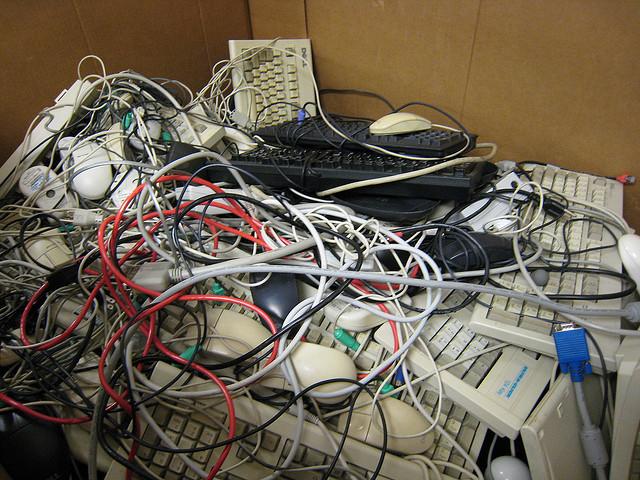Are these wires tangled?
Write a very short answer. Yes. What is this a pile of?
Short answer required. Keyboards,computer mouse and wires. Can you count all of the mice?
Give a very brief answer. No. 